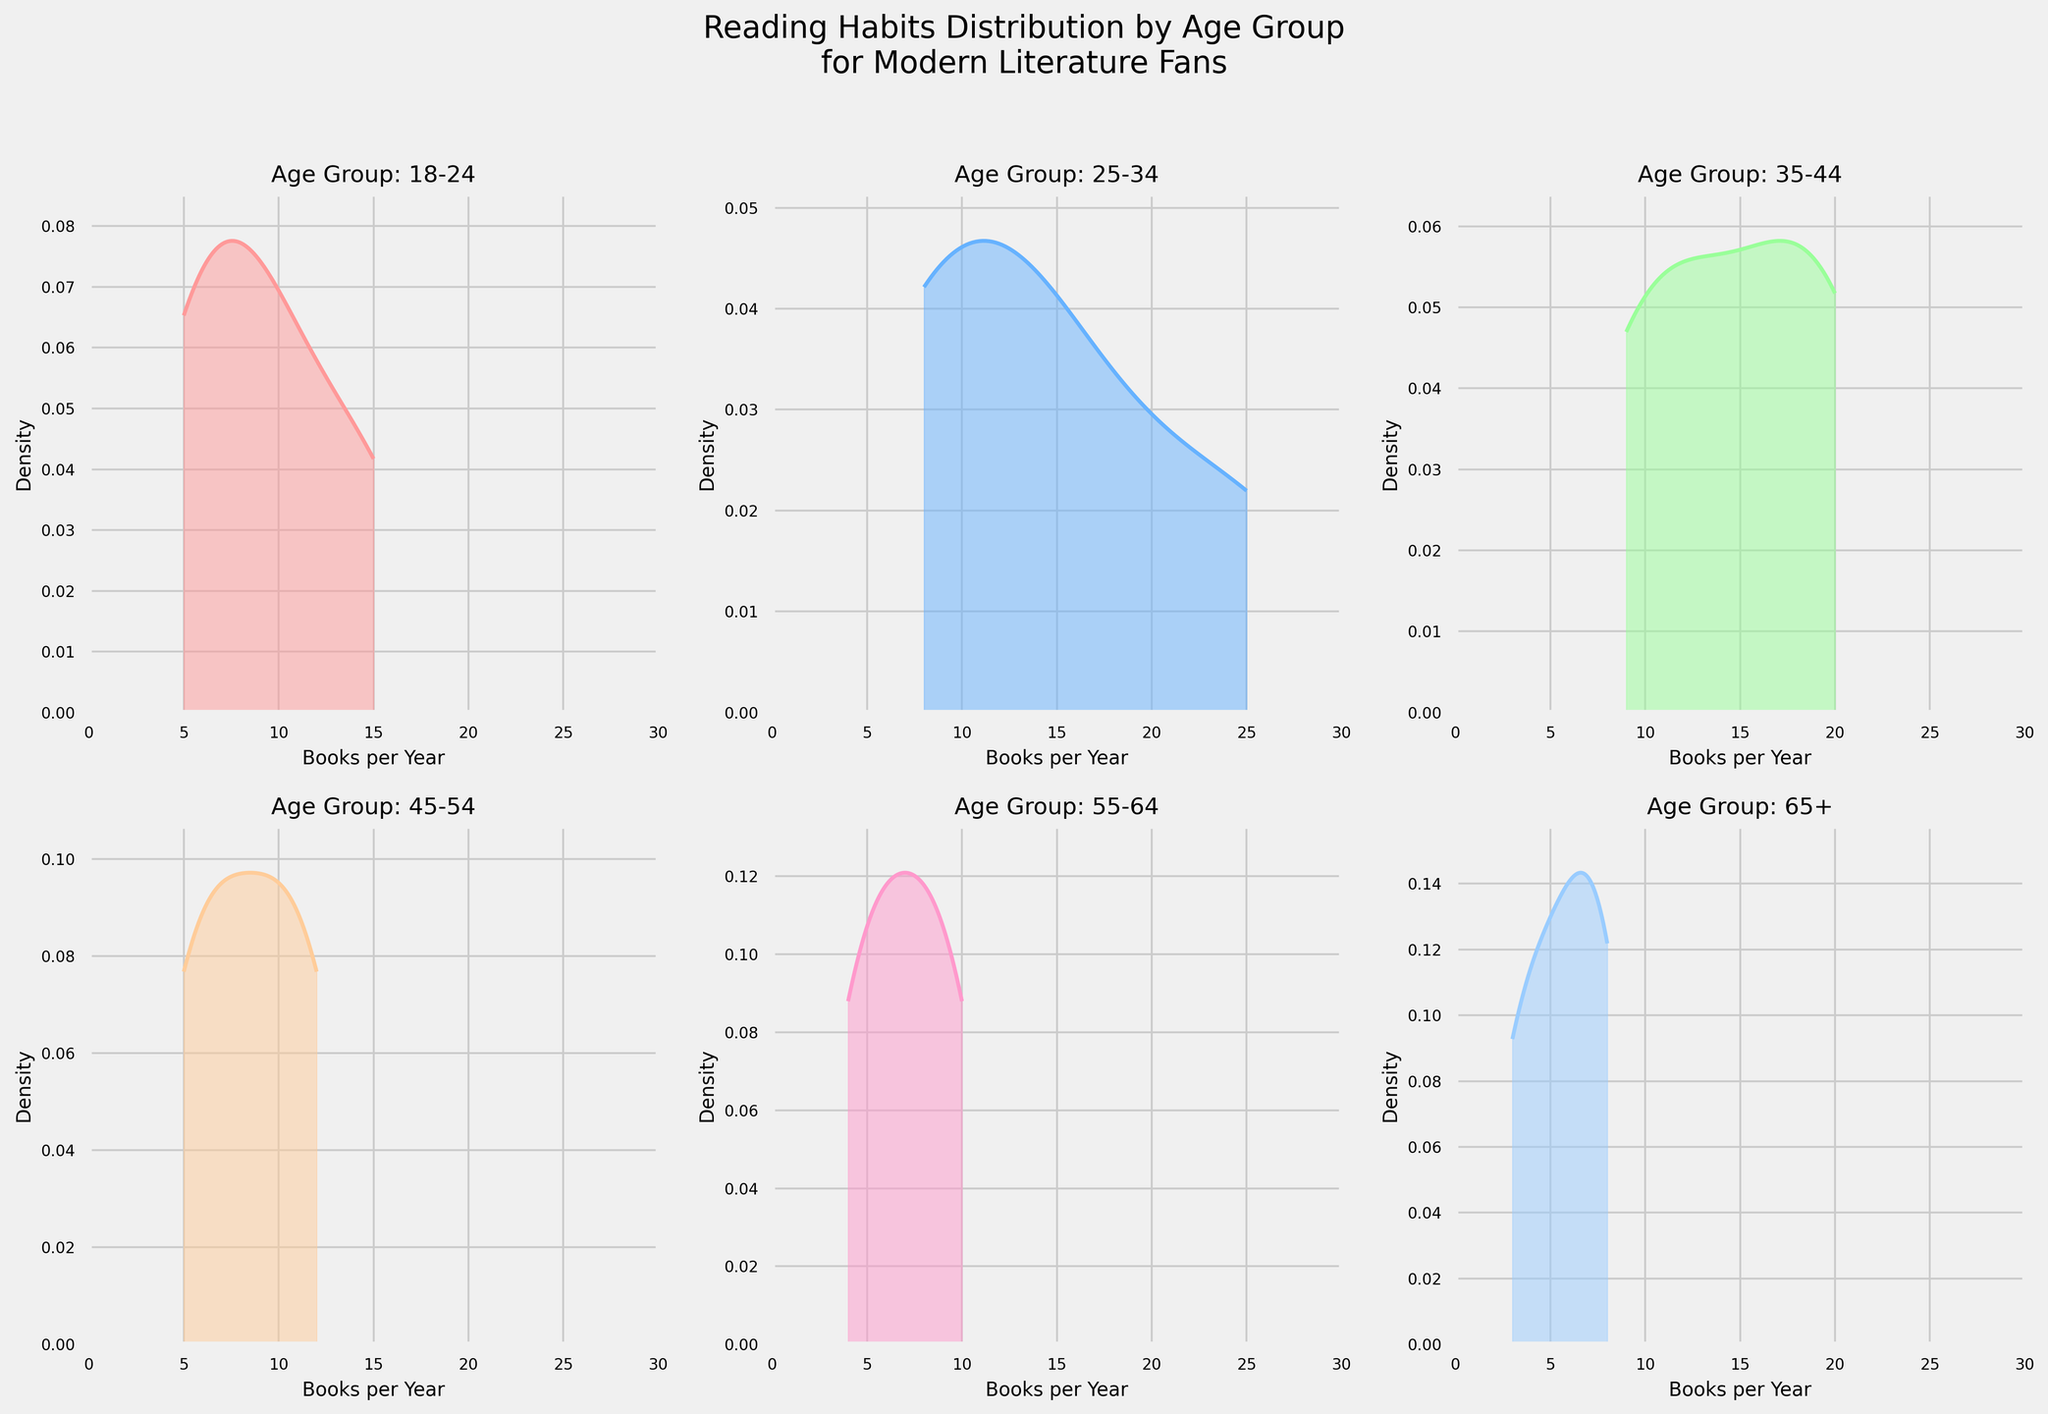What is the title of the figure? The title is presented at the top of the figure and summarizes the main subject of the data. The title reads: "Reading Habits Distribution by Age Group for Modern Literature Fans".
Answer: Reading Habits Distribution by Age Group for Modern Literature Fans How many subplots are displayed in the figure? The figure is organized in a 2x3 grid, clearly holding 6 subplots.
Answer: 6 Which age group has the highest density of people reading 25 books per year? The subplot for the 25-34 age group shows a peak around 25 books per year, indicating the highest density.
Answer: 25-34 What is the x-axis label for each subplot? Each subplot has the same x-axis label indicating the number of books read per year, labeled "Books per Year".
Answer: Books per Year Describe the y-axis label used in the subplots. The y-axis label in each subplot, representing density, is labeled simply as "Density".
Answer: Density Which age group tends to read the fewest books annually? Observing the subplots, the age group 65+ shows density curves skewed towards fewer books per year (around 5 books).
Answer: 65+ How does the density of daily readers in the 35-44 age group compare to the density of daily readers in the 18-24 age group? The subplot for the 35-44 age group shows a higher density peak around 20 books per year, whereas the 18-24 age group shows peaks around 15 books, indicating more frequent readers in the former.
Answer: Higher in 35-44 Which age group shows more reading diversity in their frequency? The age group 25-34 has a wider spread in their reading habits, indicating more diversity in the frequency of reading books per year.
Answer: 25-34 